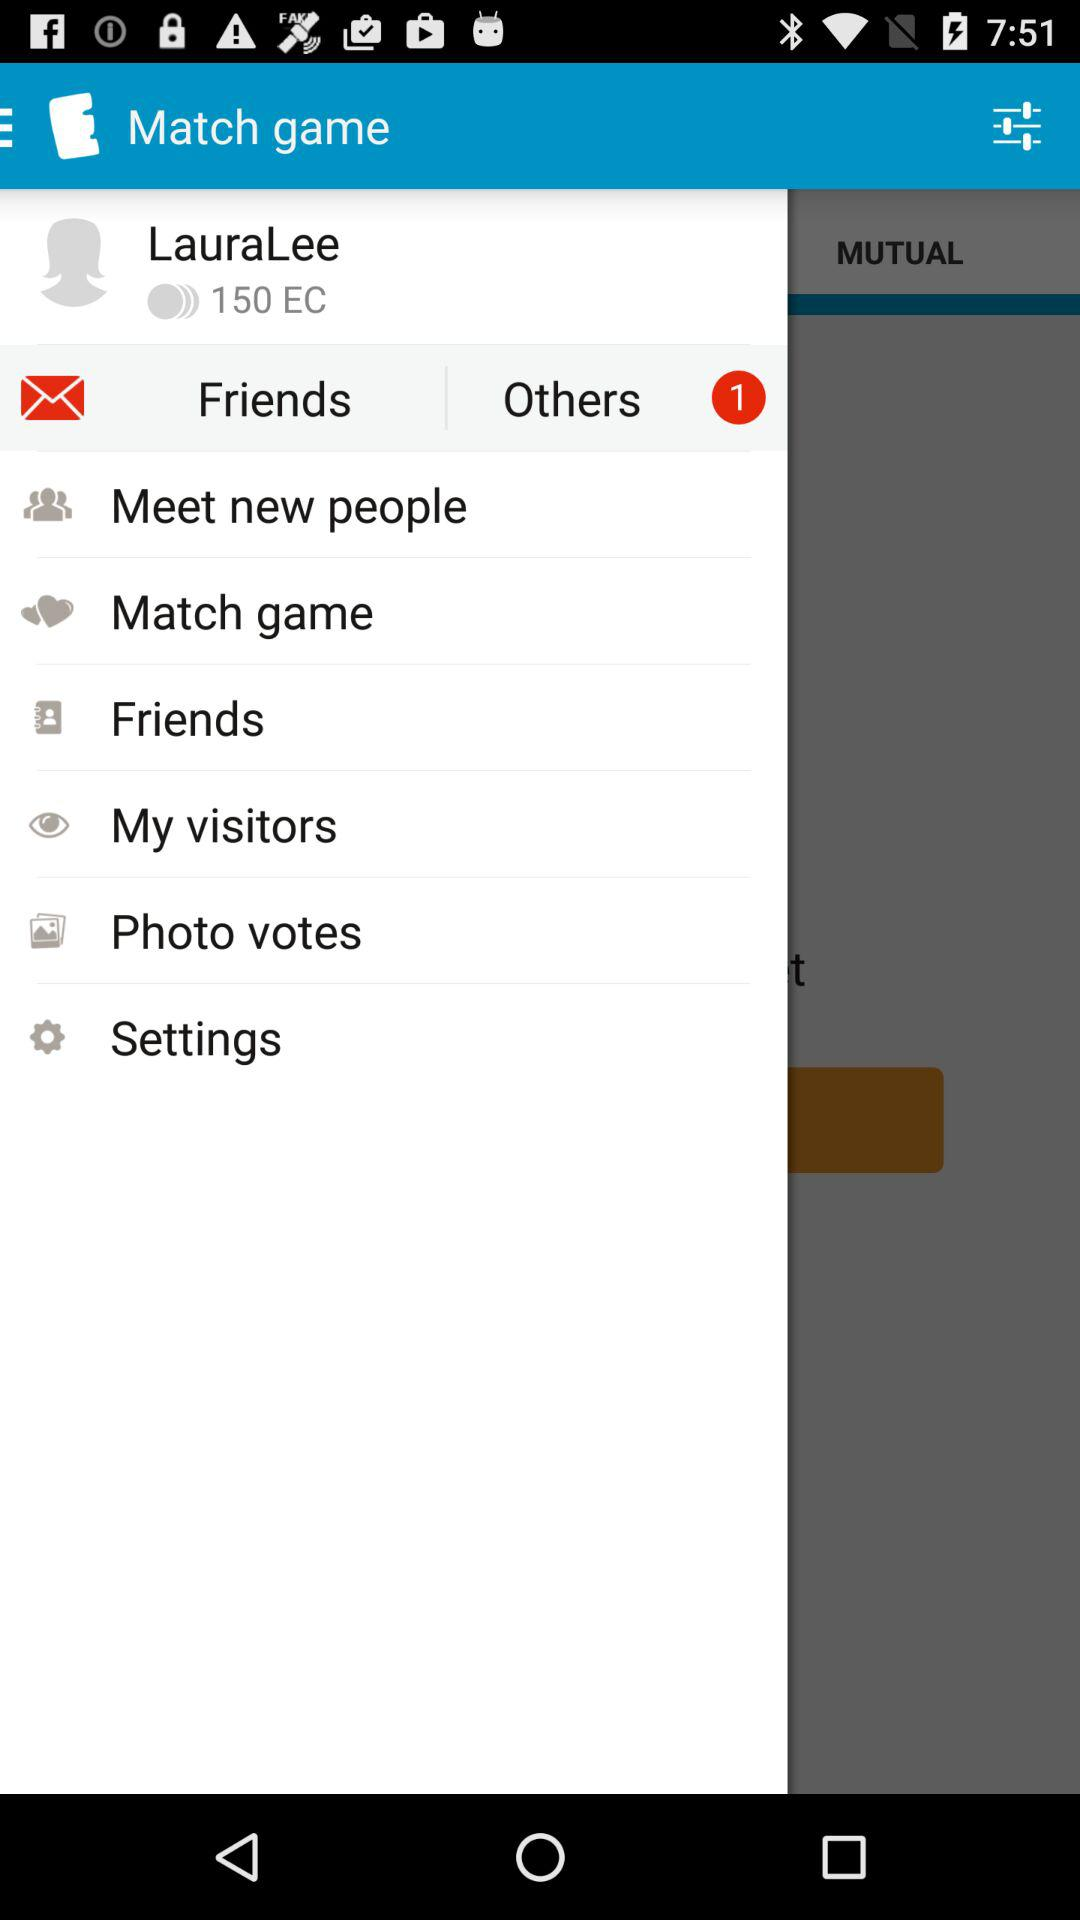How many new notifications are there? There is 1 new notification. 